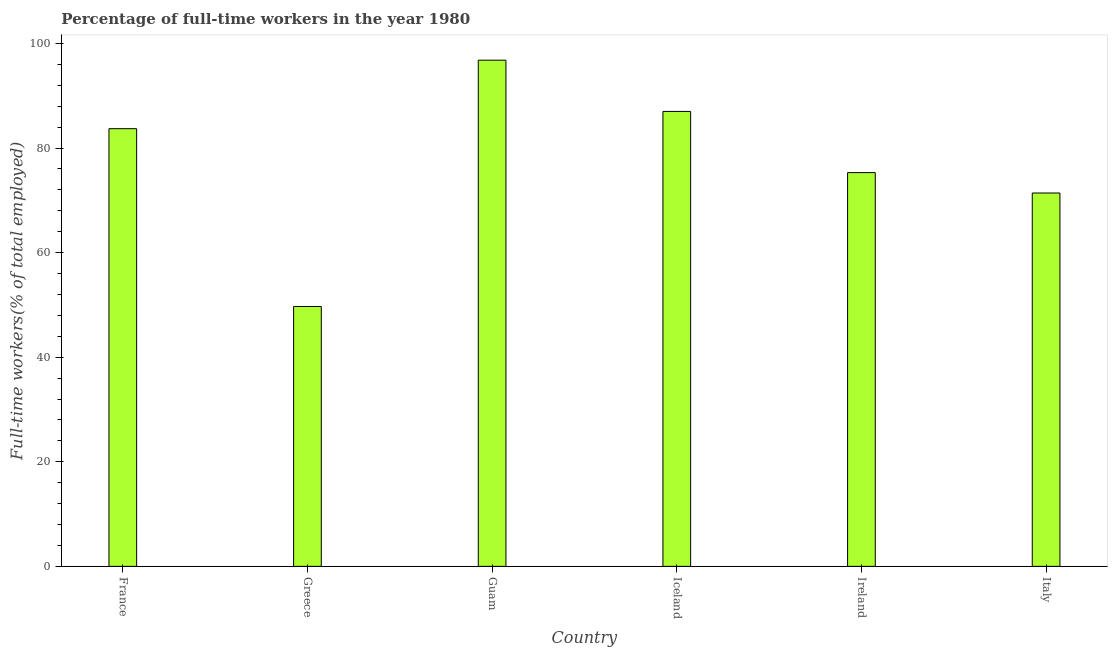Does the graph contain any zero values?
Provide a short and direct response. No. Does the graph contain grids?
Make the answer very short. No. What is the title of the graph?
Ensure brevity in your answer.  Percentage of full-time workers in the year 1980. What is the label or title of the Y-axis?
Your answer should be compact. Full-time workers(% of total employed). What is the percentage of full-time workers in Greece?
Provide a succinct answer. 49.7. Across all countries, what is the maximum percentage of full-time workers?
Offer a terse response. 96.8. Across all countries, what is the minimum percentage of full-time workers?
Your response must be concise. 49.7. In which country was the percentage of full-time workers maximum?
Your answer should be very brief. Guam. What is the sum of the percentage of full-time workers?
Your answer should be very brief. 463.9. What is the difference between the percentage of full-time workers in Greece and Ireland?
Your answer should be compact. -25.6. What is the average percentage of full-time workers per country?
Ensure brevity in your answer.  77.32. What is the median percentage of full-time workers?
Make the answer very short. 79.5. What is the ratio of the percentage of full-time workers in Greece to that in Guam?
Your answer should be compact. 0.51. What is the difference between the highest and the second highest percentage of full-time workers?
Make the answer very short. 9.8. Is the sum of the percentage of full-time workers in Iceland and Italy greater than the maximum percentage of full-time workers across all countries?
Offer a terse response. Yes. What is the difference between the highest and the lowest percentage of full-time workers?
Your answer should be compact. 47.1. Are all the bars in the graph horizontal?
Your answer should be compact. No. How many countries are there in the graph?
Offer a terse response. 6. Are the values on the major ticks of Y-axis written in scientific E-notation?
Offer a very short reply. No. What is the Full-time workers(% of total employed) of France?
Offer a very short reply. 83.7. What is the Full-time workers(% of total employed) of Greece?
Provide a succinct answer. 49.7. What is the Full-time workers(% of total employed) of Guam?
Offer a terse response. 96.8. What is the Full-time workers(% of total employed) in Iceland?
Offer a very short reply. 87. What is the Full-time workers(% of total employed) in Ireland?
Your response must be concise. 75.3. What is the Full-time workers(% of total employed) in Italy?
Give a very brief answer. 71.4. What is the difference between the Full-time workers(% of total employed) in France and Guam?
Your response must be concise. -13.1. What is the difference between the Full-time workers(% of total employed) in France and Iceland?
Give a very brief answer. -3.3. What is the difference between the Full-time workers(% of total employed) in France and Ireland?
Your answer should be compact. 8.4. What is the difference between the Full-time workers(% of total employed) in France and Italy?
Ensure brevity in your answer.  12.3. What is the difference between the Full-time workers(% of total employed) in Greece and Guam?
Your answer should be compact. -47.1. What is the difference between the Full-time workers(% of total employed) in Greece and Iceland?
Offer a very short reply. -37.3. What is the difference between the Full-time workers(% of total employed) in Greece and Ireland?
Your answer should be compact. -25.6. What is the difference between the Full-time workers(% of total employed) in Greece and Italy?
Your answer should be compact. -21.7. What is the difference between the Full-time workers(% of total employed) in Guam and Ireland?
Offer a very short reply. 21.5. What is the difference between the Full-time workers(% of total employed) in Guam and Italy?
Your answer should be compact. 25.4. What is the difference between the Full-time workers(% of total employed) in Iceland and Italy?
Offer a terse response. 15.6. What is the difference between the Full-time workers(% of total employed) in Ireland and Italy?
Offer a terse response. 3.9. What is the ratio of the Full-time workers(% of total employed) in France to that in Greece?
Give a very brief answer. 1.68. What is the ratio of the Full-time workers(% of total employed) in France to that in Guam?
Offer a very short reply. 0.86. What is the ratio of the Full-time workers(% of total employed) in France to that in Ireland?
Make the answer very short. 1.11. What is the ratio of the Full-time workers(% of total employed) in France to that in Italy?
Provide a succinct answer. 1.17. What is the ratio of the Full-time workers(% of total employed) in Greece to that in Guam?
Provide a short and direct response. 0.51. What is the ratio of the Full-time workers(% of total employed) in Greece to that in Iceland?
Keep it short and to the point. 0.57. What is the ratio of the Full-time workers(% of total employed) in Greece to that in Ireland?
Your response must be concise. 0.66. What is the ratio of the Full-time workers(% of total employed) in Greece to that in Italy?
Offer a terse response. 0.7. What is the ratio of the Full-time workers(% of total employed) in Guam to that in Iceland?
Keep it short and to the point. 1.11. What is the ratio of the Full-time workers(% of total employed) in Guam to that in Ireland?
Provide a short and direct response. 1.29. What is the ratio of the Full-time workers(% of total employed) in Guam to that in Italy?
Your response must be concise. 1.36. What is the ratio of the Full-time workers(% of total employed) in Iceland to that in Ireland?
Provide a short and direct response. 1.16. What is the ratio of the Full-time workers(% of total employed) in Iceland to that in Italy?
Offer a terse response. 1.22. What is the ratio of the Full-time workers(% of total employed) in Ireland to that in Italy?
Provide a short and direct response. 1.05. 